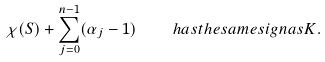<formula> <loc_0><loc_0><loc_500><loc_500>\chi ( S ) + \sum _ { j = 0 } ^ { n - 1 } ( \alpha _ { j } - 1 ) \quad h a s t h e s a m e s i g n a s K .</formula> 